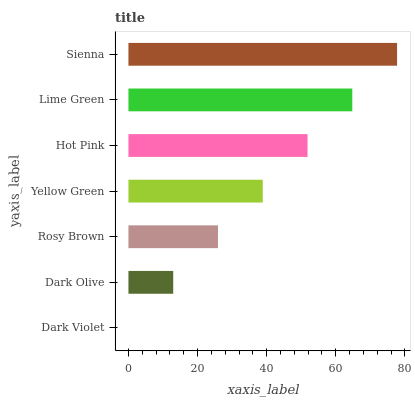Is Dark Violet the minimum?
Answer yes or no. Yes. Is Sienna the maximum?
Answer yes or no. Yes. Is Dark Olive the minimum?
Answer yes or no. No. Is Dark Olive the maximum?
Answer yes or no. No. Is Dark Olive greater than Dark Violet?
Answer yes or no. Yes. Is Dark Violet less than Dark Olive?
Answer yes or no. Yes. Is Dark Violet greater than Dark Olive?
Answer yes or no. No. Is Dark Olive less than Dark Violet?
Answer yes or no. No. Is Yellow Green the high median?
Answer yes or no. Yes. Is Yellow Green the low median?
Answer yes or no. Yes. Is Dark Olive the high median?
Answer yes or no. No. Is Sienna the low median?
Answer yes or no. No. 